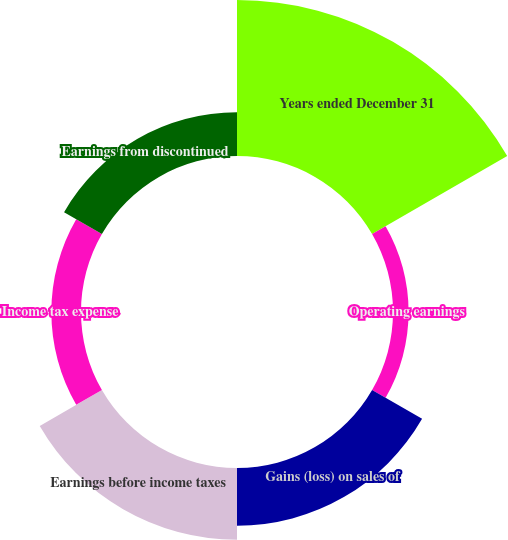Convert chart. <chart><loc_0><loc_0><loc_500><loc_500><pie_chart><fcel>Years ended December 31<fcel>Operating earnings<fcel>Gains (loss) on sales of<fcel>Earnings before income taxes<fcel>Income tax expense<fcel>Earnings from discontinued<nl><fcel>41.67%<fcel>4.16%<fcel>15.42%<fcel>19.17%<fcel>7.92%<fcel>11.67%<nl></chart> 